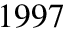Convert formula to latex. <formula><loc_0><loc_0><loc_500><loc_500>1 9 9 7</formula> 